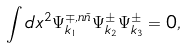<formula> <loc_0><loc_0><loc_500><loc_500>\int d x ^ { 2 } \Psi ^ { \mp , n \tilde { n } } _ { k _ { 1 } } \Psi ^ { \pm } _ { k _ { 2 } } \Psi ^ { \pm } _ { k _ { 3 } } = 0 ,</formula> 